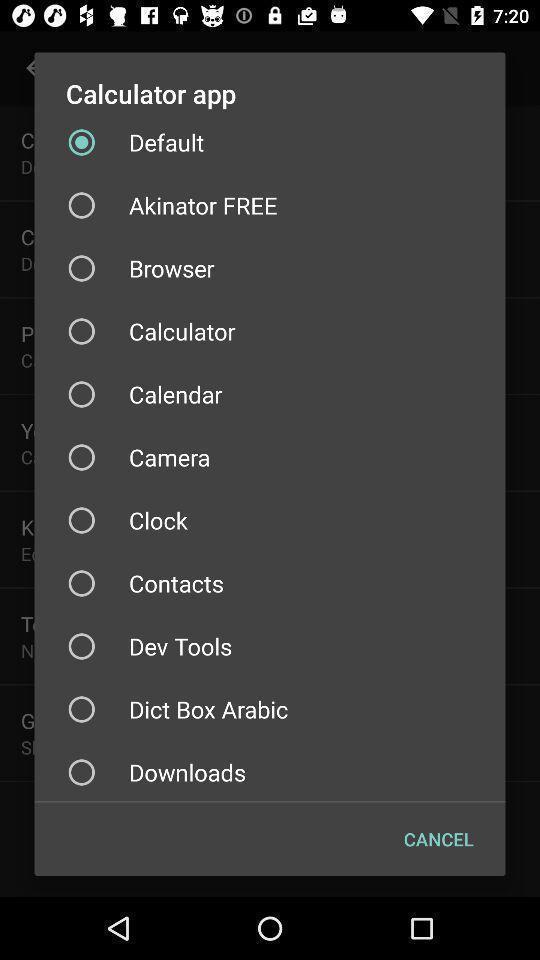What details can you identify in this image? Push up displaying list of various apps. 